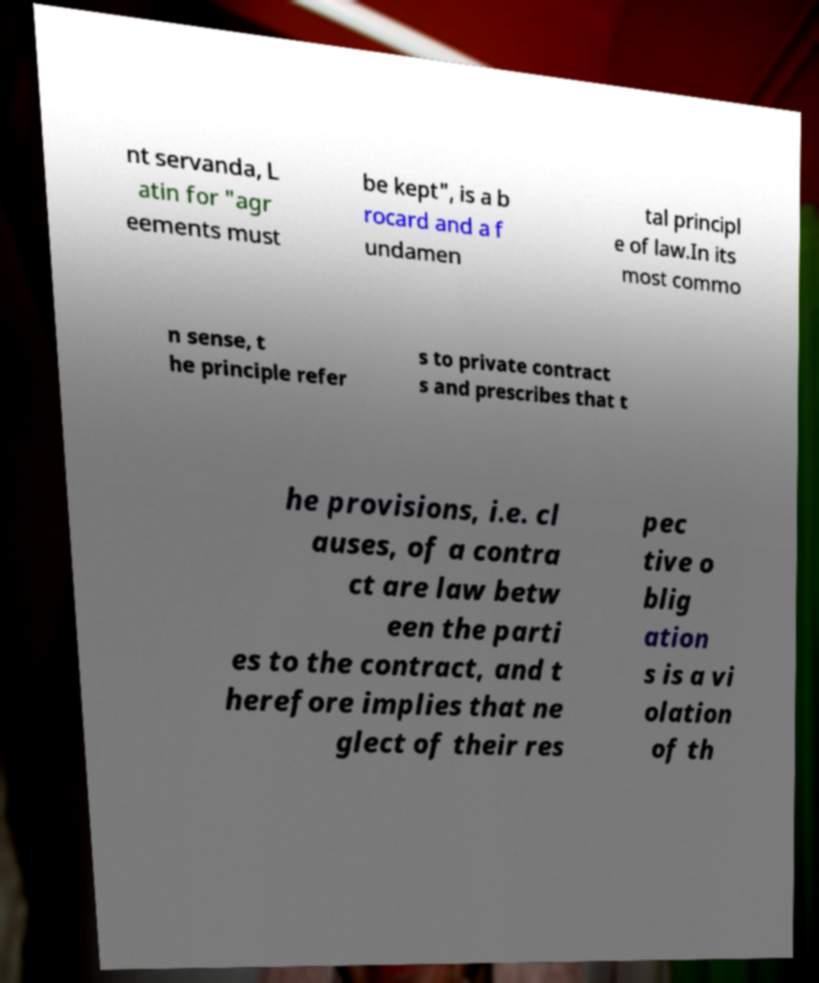Can you read and provide the text displayed in the image?This photo seems to have some interesting text. Can you extract and type it out for me? nt servanda, L atin for "agr eements must be kept", is a b rocard and a f undamen tal principl e of law.In its most commo n sense, t he principle refer s to private contract s and prescribes that t he provisions, i.e. cl auses, of a contra ct are law betw een the parti es to the contract, and t herefore implies that ne glect of their res pec tive o blig ation s is a vi olation of th 